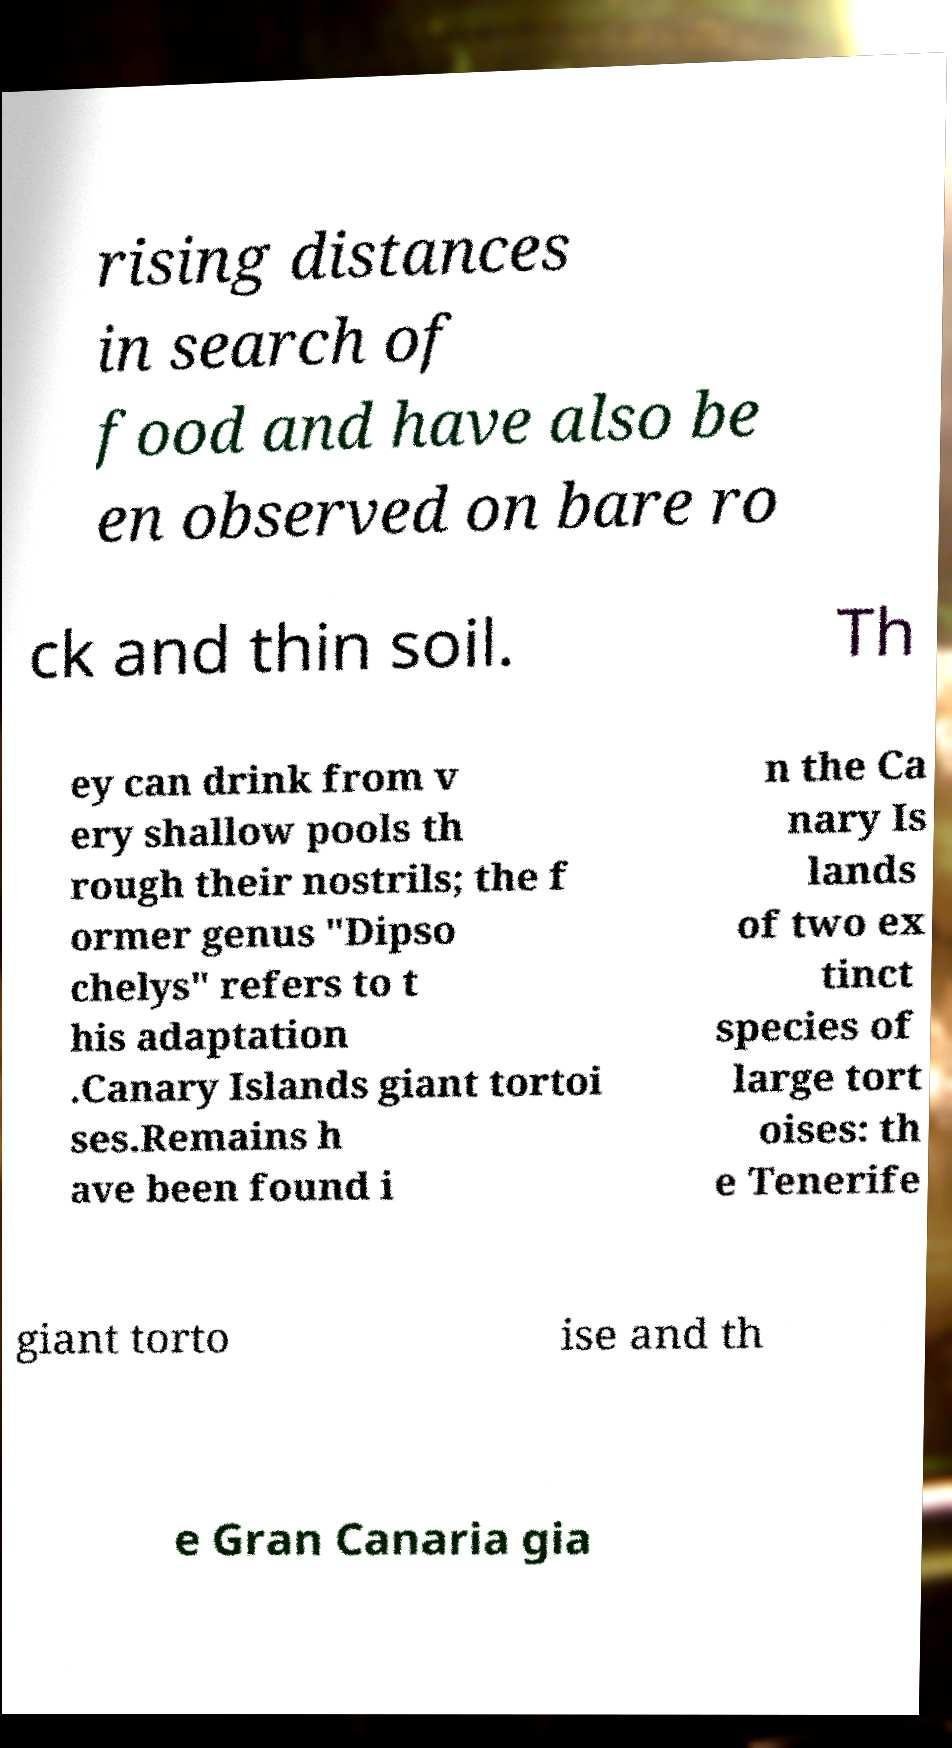Could you extract and type out the text from this image? rising distances in search of food and have also be en observed on bare ro ck and thin soil. Th ey can drink from v ery shallow pools th rough their nostrils; the f ormer genus "Dipso chelys" refers to t his adaptation .Canary Islands giant tortoi ses.Remains h ave been found i n the Ca nary Is lands of two ex tinct species of large tort oises: th e Tenerife giant torto ise and th e Gran Canaria gia 